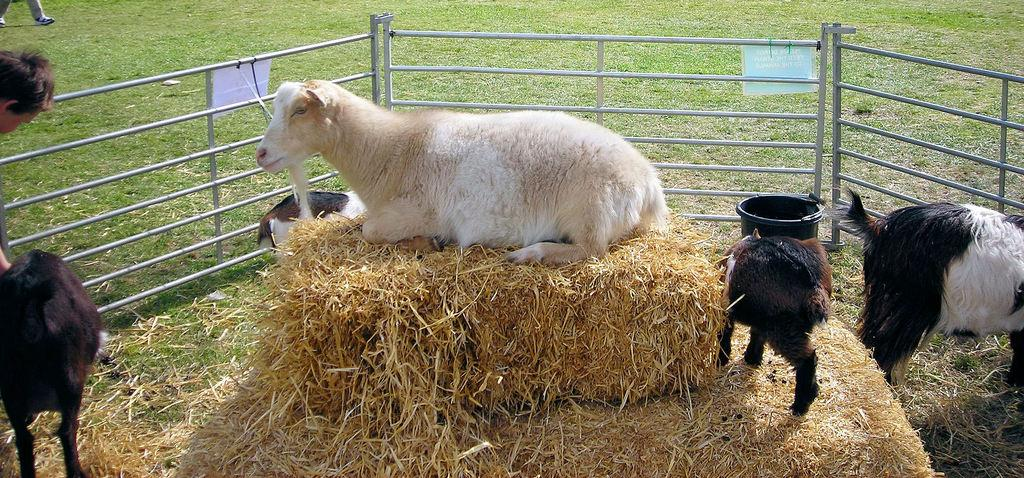What types of living organisms can be seen in the image? There are animals and people in the image. What can be seen in the background of the image? There is grass, a bucket, and other objects in the background of the image. Can you describe the setting where the animals and people are located? The setting appears to be outdoors, given the presence of grass in the background. What type of wrench is being used by the animals in the image? There is no wrench present in the image. What kind of toys can be seen in the hands of the people in the image? There is no mention of toys in the image; it only states that there are people and animals present. 